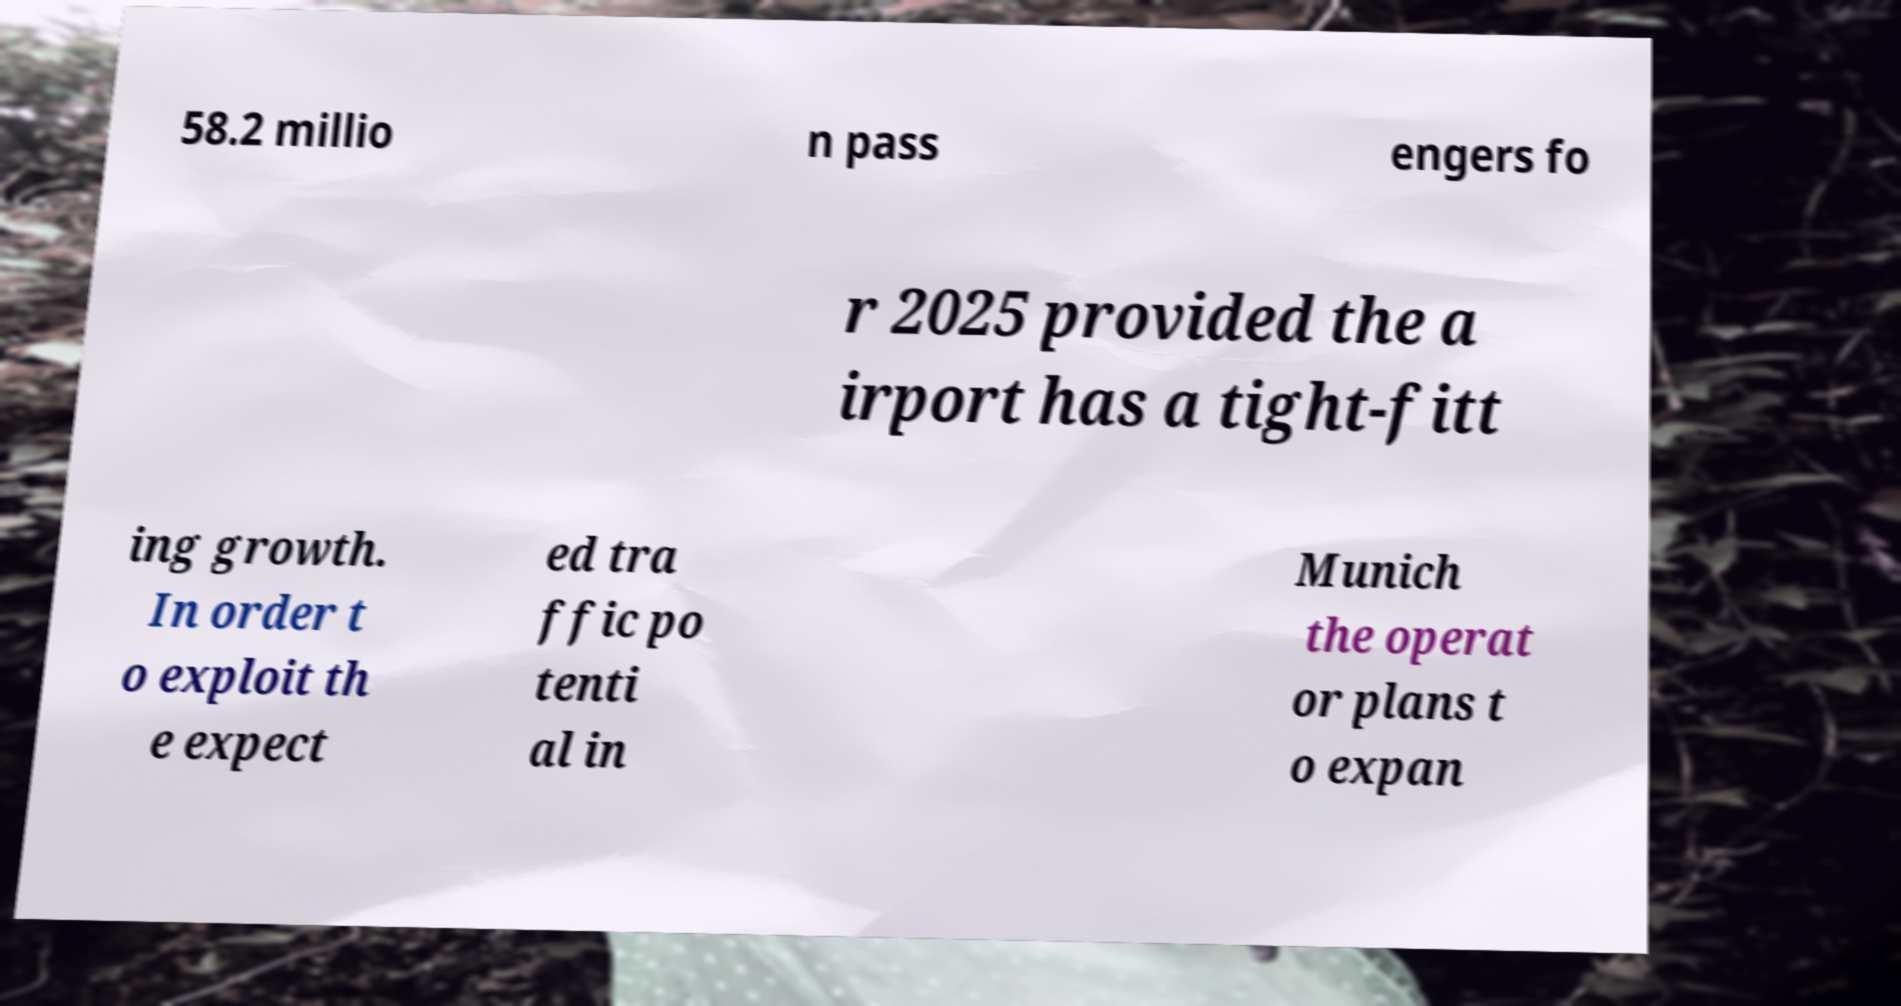For documentation purposes, I need the text within this image transcribed. Could you provide that? 58.2 millio n pass engers fo r 2025 provided the a irport has a tight-fitt ing growth. In order t o exploit th e expect ed tra ffic po tenti al in Munich the operat or plans t o expan 